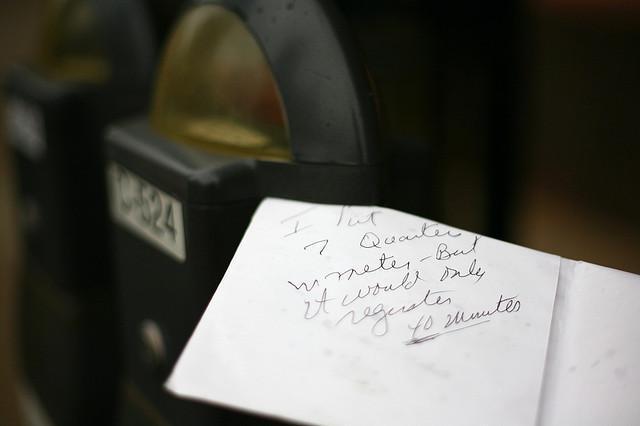How many parking meters are in the photo?
Give a very brief answer. 2. 